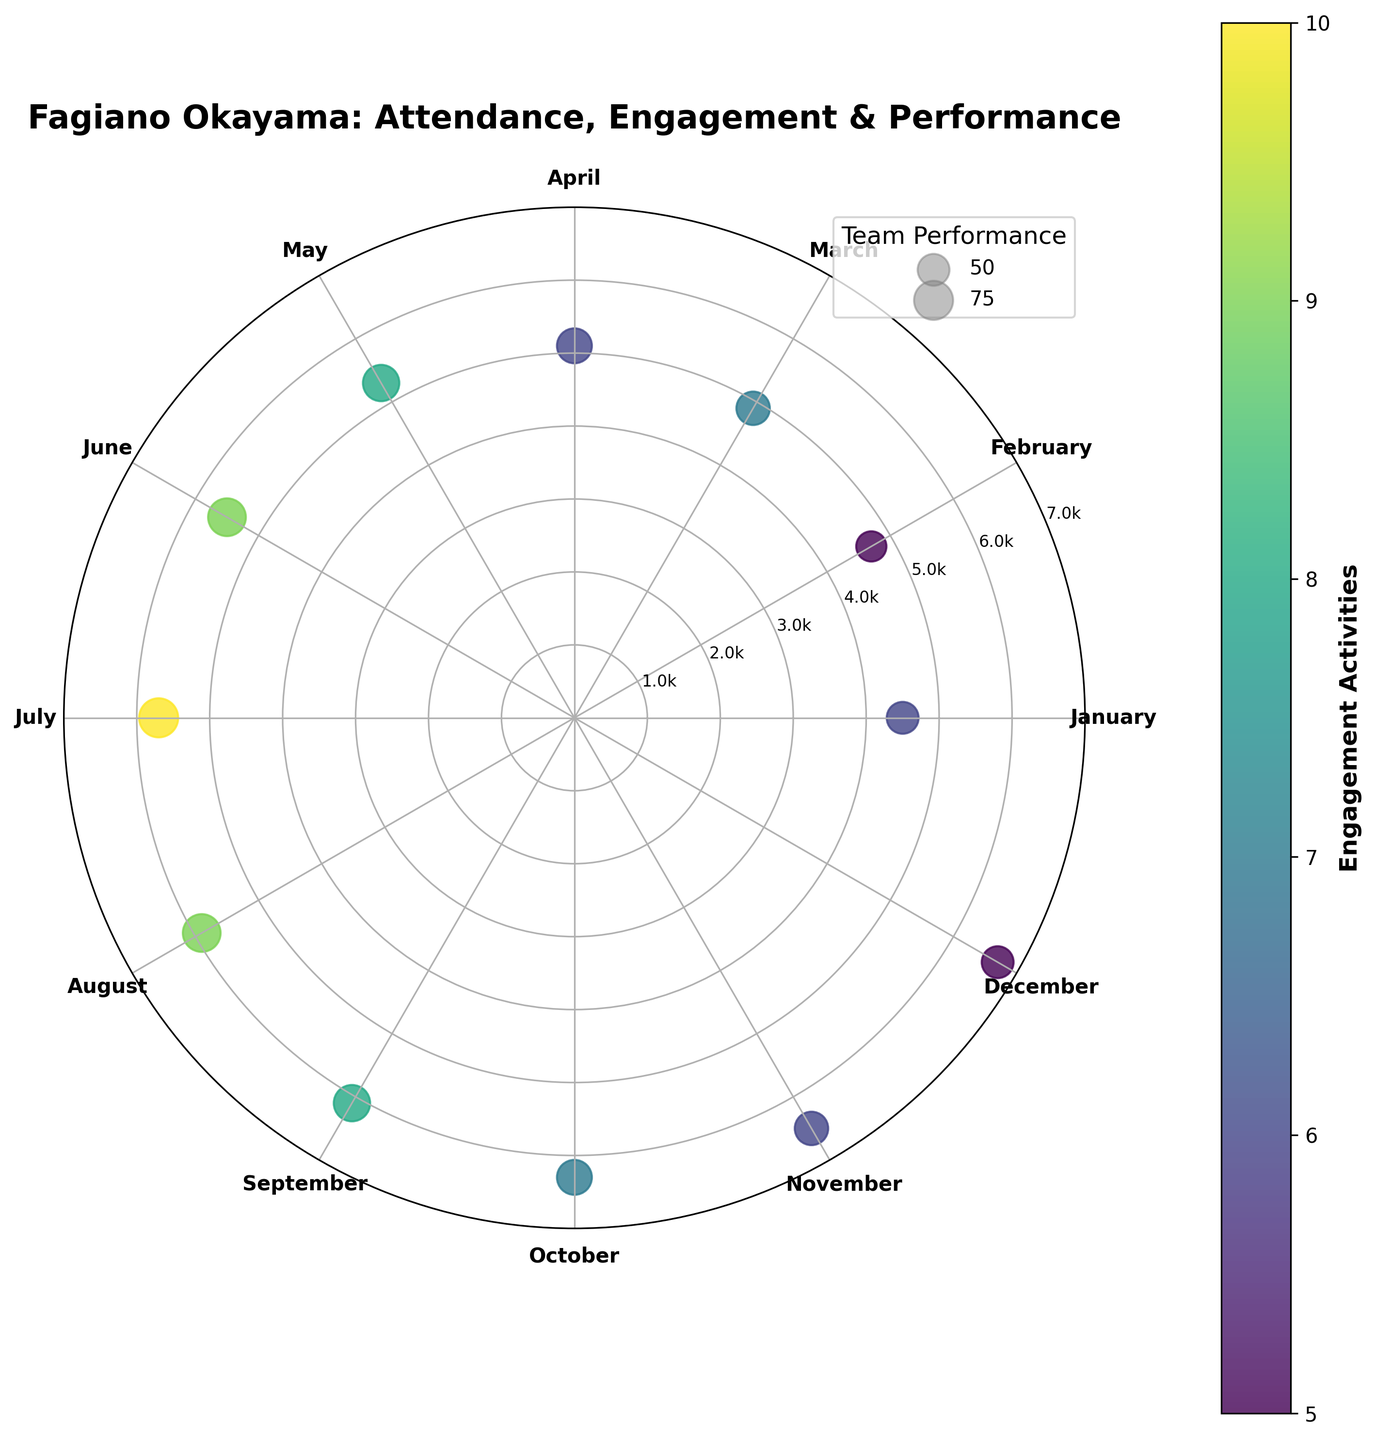What is the title of the chart? The title of the chart is displayed at the top. It reads "Fagiano Okayama: Attendance, Engagement & Performance".
Answer: Fagiano Okayama: Attendance, Engagement & Performance How many months are represented in the chart? There are 12 months represented in the chart, one for each month of the year. This can be inferred from the 12 points scattered around the polar plot, each labeled with a different month.
Answer: 12 What is the range for attendance in the chart? The y-axis values displayed around the chart range from 0 to 7000, and the scatter points corresponding to attendance are within this range.
Answer: 0 to 7000 Which month had the highest team performance? By looking at the size of the scatter points, the largest point corresponds to the highest team performance. July has the largest point, corresponding to a team performance score of 75.
Answer: July In which month did the team see the most engagement activities? The color of the scatter points represents engagement activities, with darker colors indicating higher engagement. July has the darkest color, indicating 10 engagement activities, the highest value.
Answer: July What months saw a team performance of 50? From the legend, the larger points correspond to team performance. By comparing point sizes, January and December both show smaller, identical points indicating a team performance of 50.
Answer: January and December What is the average attendance for the first half of the year? The first half of the year includes January to June. The average attendance can be calculated as (4500 + 4700 + 4900 + 5100 + 5300 + 5500) / 6 = 5000.
Answer: 5000 Compare the attendance in July and August. Which is higher? The y-axis values indicate the attendance. July has an attendance of 5700, and August has an attendance of 5900. Therefore, August has higher attendance than July.
Answer: August What is the trend in team performance from January to December? Observing the size of the scatter points from January to December shows an increase from January to July, peaking in July, and then decreasing again toward December.
Answer: Increases then decreases During which month is the attendance closest to 6000? The y-axis scale is used to determine the attendance values. September's attendance is 6100, which is the closest to 6000.
Answer: September 